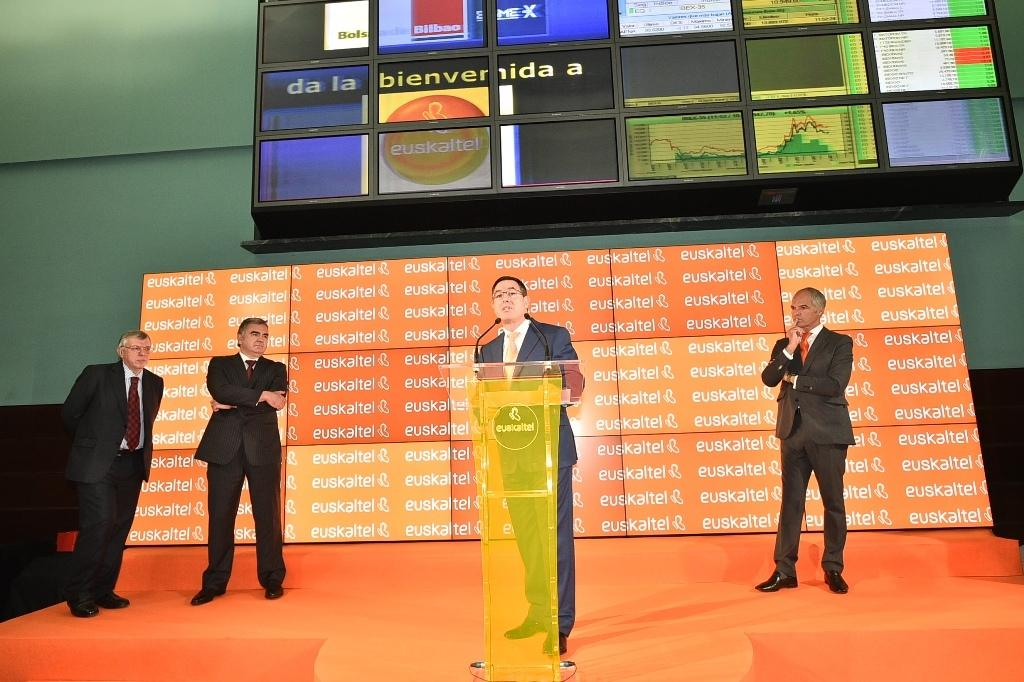What is located above the stage in the image? There is a podium above the stage. How many people are near the podium? There are four people near the podium. What can be seen in the background of the image? There are hoardings and a wall in the background. What type of car is parked near the podium in the image? There is no car present in the image; it only features a podium, four people, hoardings, and a wall in the background. What historical event is being commemorated in the image? There is no indication of a historical event being commemorated in the image. 